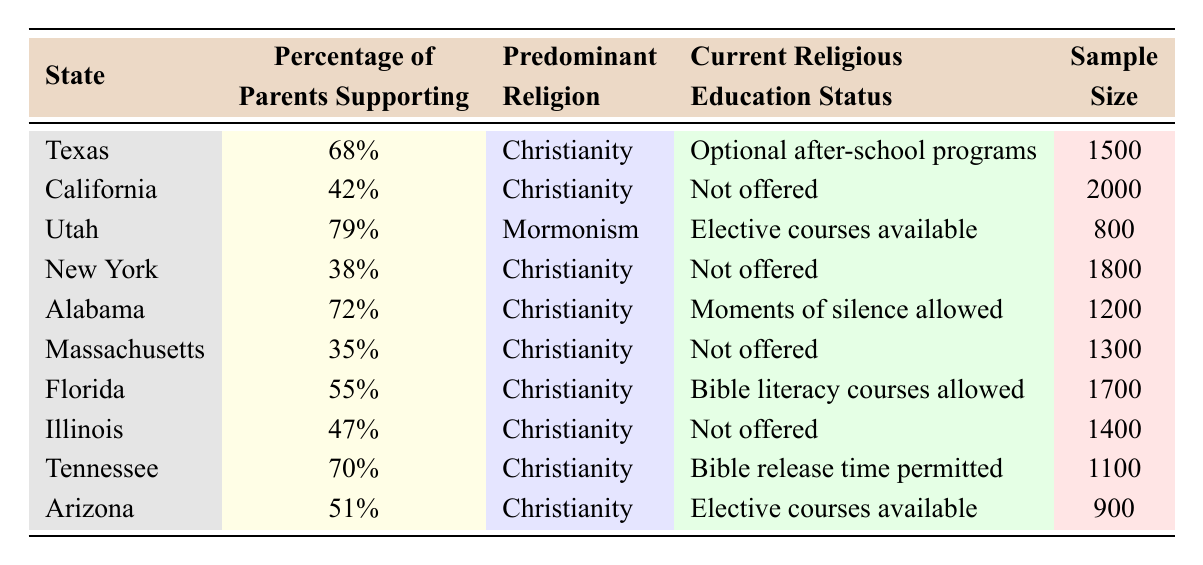What percentage of parents in Texas support religious education? The table indicates that the percentage of parents supporting religious education in Texas is listed as 68%.
Answer: 68% Which state has the highest percentage of parental support for religious education? By scanning the table, Utah is shown to have the highest percentage of parental support, at 79%.
Answer: Utah Is religious education offered in California? The table states that religious education is not offered in California, which is mentioned in the "Current Religious Education Status" column.
Answer: No What is the average percentage of parental support for religious education across all states listed? The percentages for each state are 68%, 42%, 79%, 38%, 72%, 35%, 55%, 47%, 70%, and 51%. Adding these yields 68 + 42 + 79 + 38 + 72 + 35 + 55 + 47 + 70 + 51 =  516. There are 10 states, so the average is 516/10 = 51.6%.
Answer: 51.6% How many states have a percentage of parental support greater than 70%? Checking the percentages, Texas (68%), Alabama (72%), Utah (79%), and Tennessee (70%) are above 70%. Hence, there are 4 states with support greater than 70%.
Answer: 4 What is the predominant religion in Alabama? The table lists "Christianity" as the predominant religion in Alabama under the respective column.
Answer: Christianity What is the percentage difference between the highest and lowest support for religious education? The highest support is in Utah at 79% and the lowest is in Massachusetts at 35%. The difference is 79% - 35% = 44%.
Answer: 44% What type of religious education status is mentioned for Florida? The table specifies that Bible literacy courses are allowed in Florida under the "Current Religious Education Status" column.
Answer: Bible literacy courses allowed Which state does not offer religious education at all? California, New York, Massachusetts, and Illinois all have a status of "Not offered" for religious education according to the table.
Answer: California, New York, Massachusetts, Illinois Are there more states with mandatory religious education or optional programs? The table indicates that "Optional after-school programs" are in Texas, while "Not offered" is in several states (California, New York, Massachusetts, Illinois). Two states offer "elective courses available" (Utah and Arizona), and Alabama allows a moments of silence. This suggests more states do not offer any form of religious education. Hence, the answer is that there are more that do not offer than those with optional programs.
Answer: More states do not offer religious education 